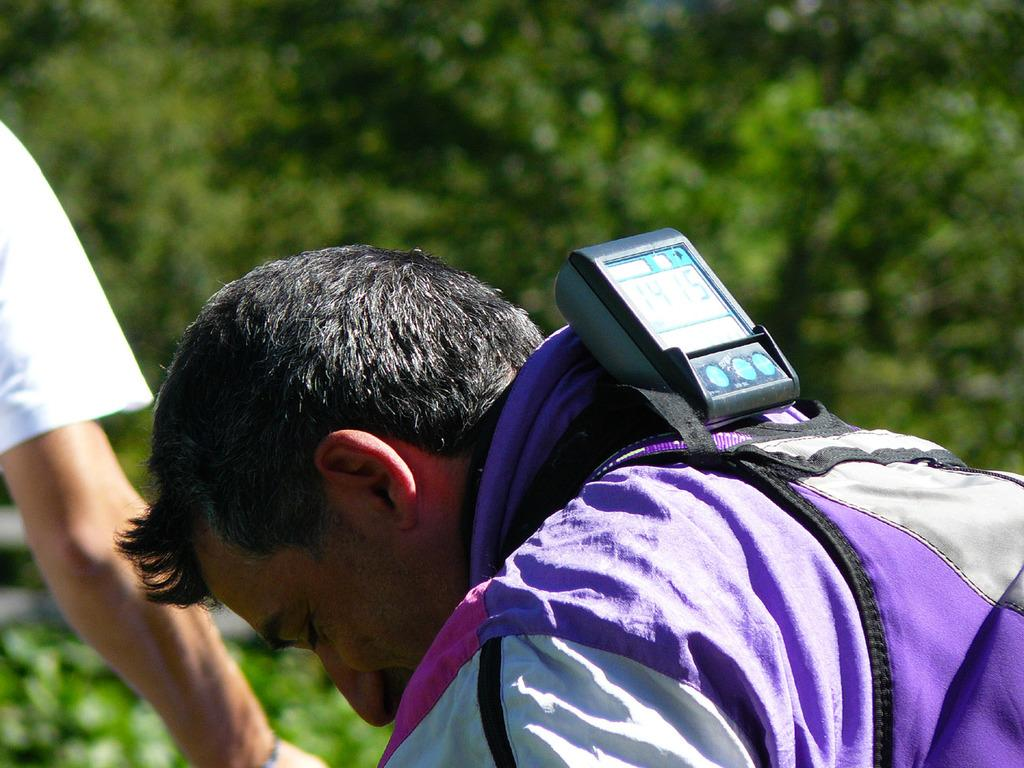How many people are present in the image? There are two people in the image. What type of object can be seen in the image that is related to electricity? There is an electrical equipment in the image. What type of natural vegetation is visible in the image? There are trees in the image. What type of soap is being used by the people in the image? There is no soap present in the image, and it is not mentioned that the people are using any soap. 